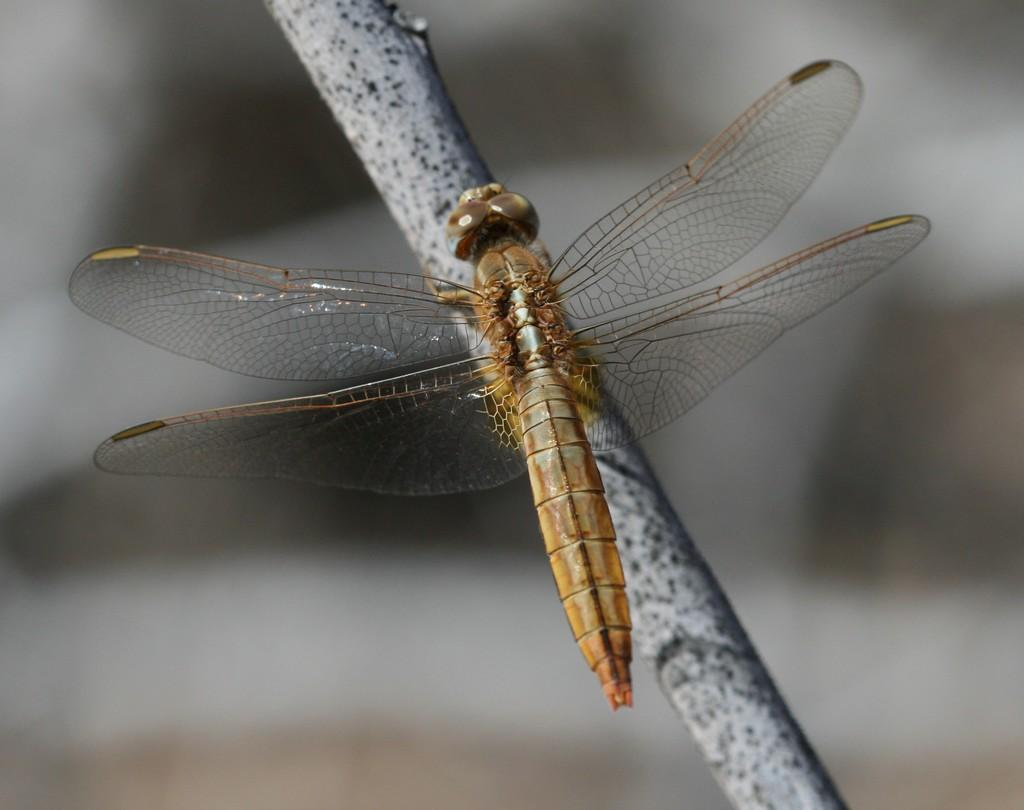What insect is present in the image? There is a dragonfly in the image. What is the dragonfly standing on? The dragonfly is standing on a stem. What type of learning material can be seen in the image? There is no learning material present in the image; it features a dragonfly standing on a stem. What kind of ring is visible on the dragonfly's leg in the image? There is no ring visible on the dragonfly's leg in the image; it is a natural insect. 